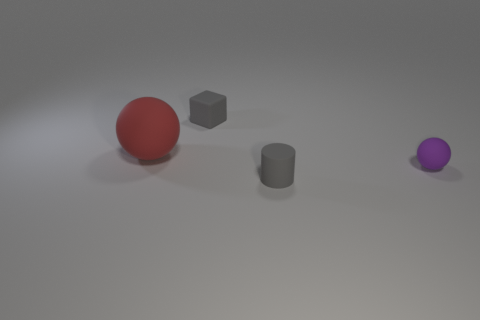Can you tell what time of day it is or where this picture might have been taken? Given that the image is a 3D rendering, there's no actual time of day or real-world location associated with it. The lighting is artificial and controlled within the rendering software to create the appearance of a potentially soft, diffused light source from above, which doesn't correlate with a specific time of day or location. 